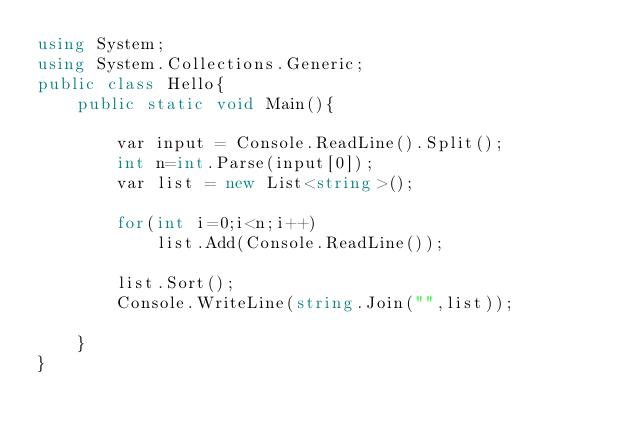Convert code to text. <code><loc_0><loc_0><loc_500><loc_500><_C#_>using System;
using System.Collections.Generic;
public class Hello{
    public static void Main(){
        
        var input = Console.ReadLine().Split();
        int n=int.Parse(input[0]);
        var list = new List<string>();
        
        for(int i=0;i<n;i++)
            list.Add(Console.ReadLine());
        
        list.Sort();
        Console.WriteLine(string.Join("",list));
        
    }
}
</code> 